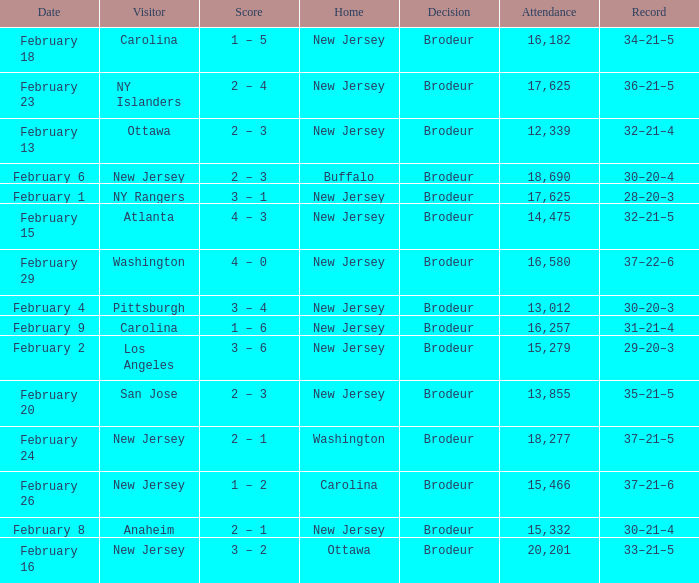What was the score when the NY Islanders was the visiting team? 2 – 4. 